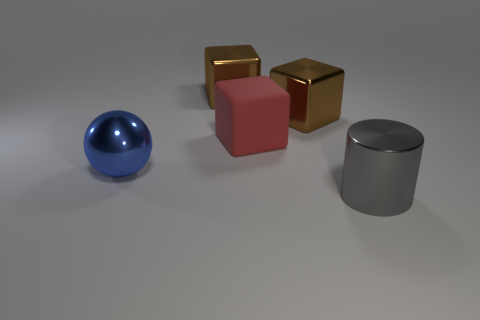Add 5 small gray cubes. How many objects exist? 10 Subtract all spheres. How many objects are left? 4 Subtract all cylinders. Subtract all shiny objects. How many objects are left? 0 Add 5 rubber things. How many rubber things are left? 6 Add 1 large cylinders. How many large cylinders exist? 2 Subtract 2 brown blocks. How many objects are left? 3 